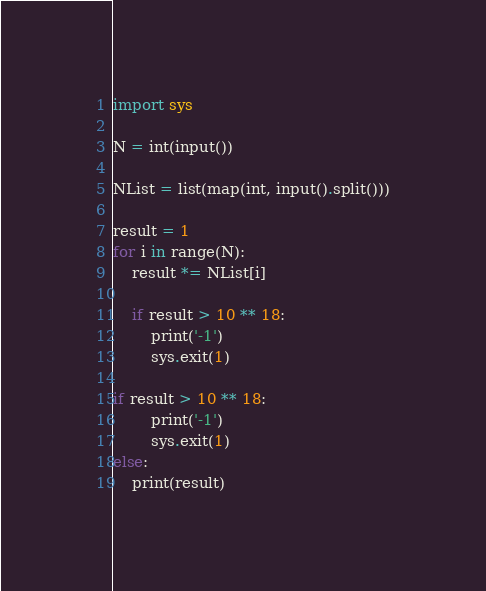<code> <loc_0><loc_0><loc_500><loc_500><_Python_>import sys

N = int(input())

NList = list(map(int, input().split()))

result = 1
for i in range(N):
    result *= NList[i]
    
    if result > 10 ** 18:
        print('-1')
        sys.exit(1)

if result > 10 ** 18:
        print('-1')
        sys.exit(1)
else:
    print(result)</code> 